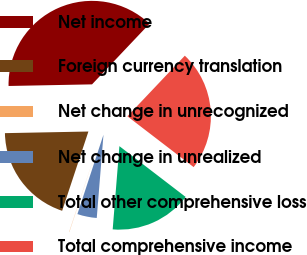Convert chart to OTSL. <chart><loc_0><loc_0><loc_500><loc_500><pie_chart><fcel>Net income<fcel>Foreign currency translation<fcel>Net change in unrecognized<fcel>Net change in unrealized<fcel>Total other comprehensive loss<fcel>Total comprehensive income<nl><fcel>37.38%<fcel>19.6%<fcel>0.04%<fcel>3.77%<fcel>15.87%<fcel>23.34%<nl></chart> 